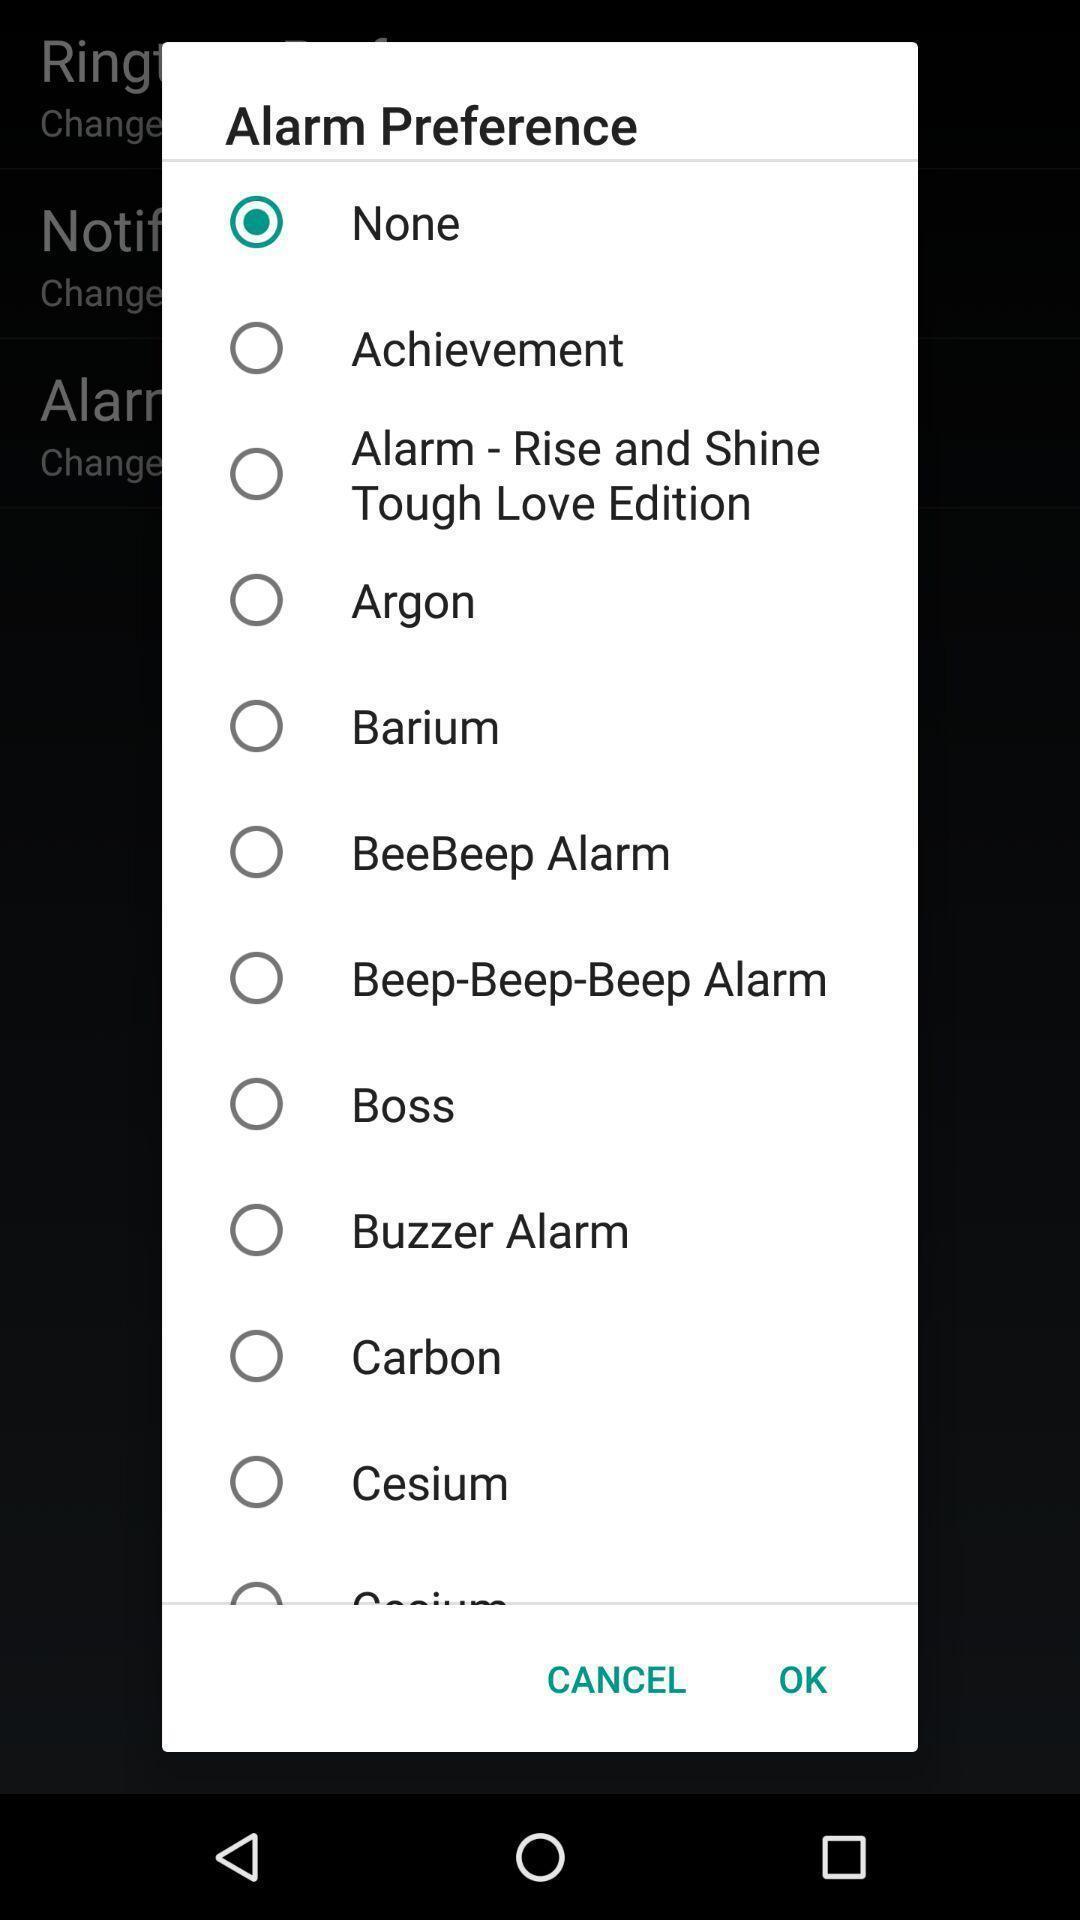Explain what's happening in this screen capture. Pop-up shows to set a tone for alarm. 